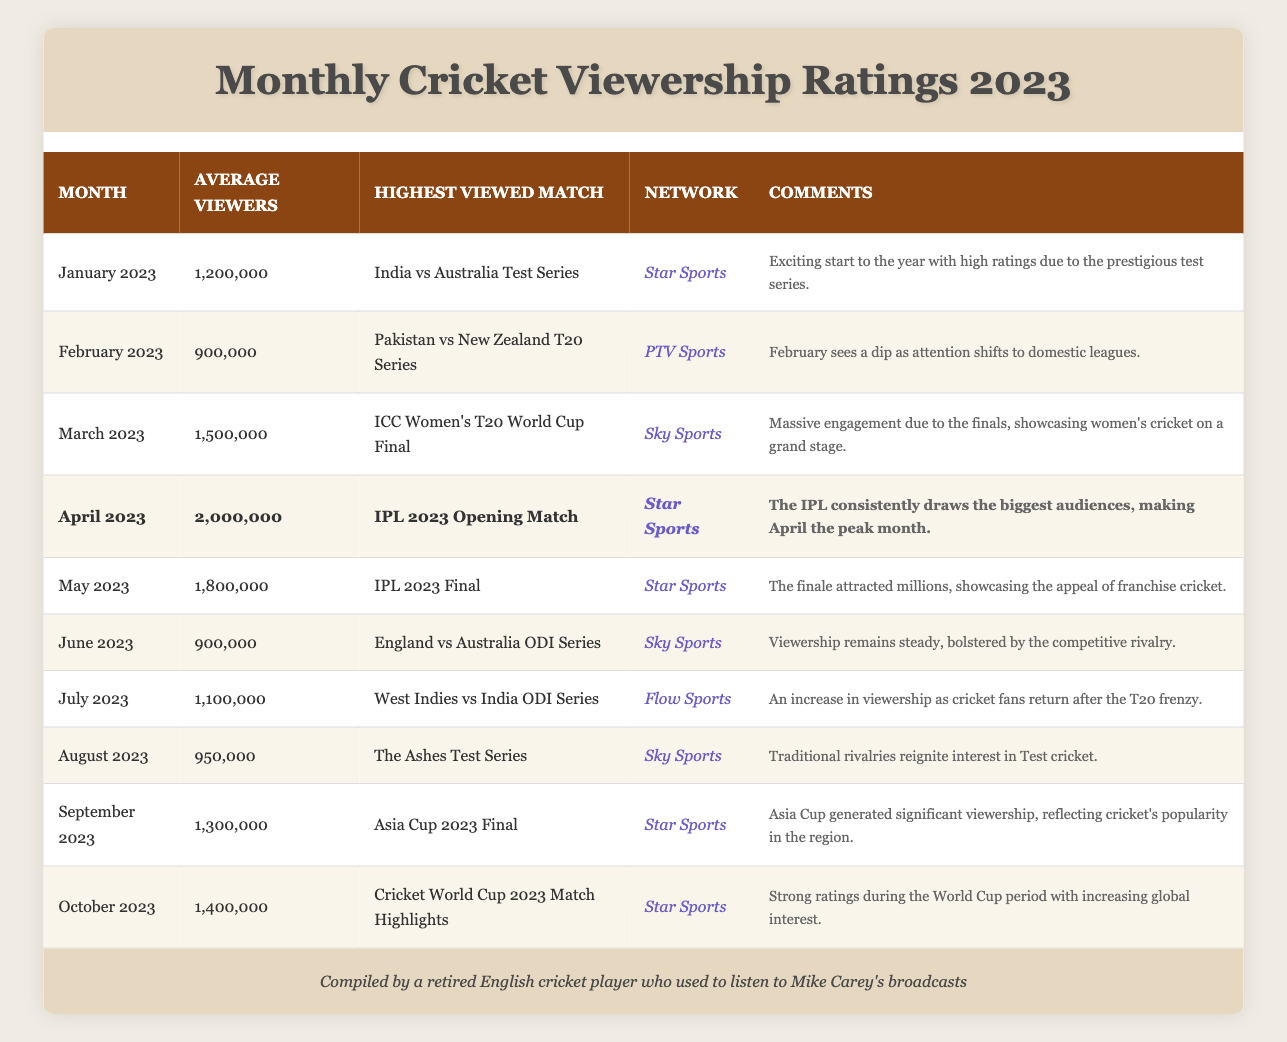What was the highest average viewership in 2023? The highest average viewership listed in the table is in April 2023, which has 2,000,000 viewers.
Answer: 2,000,000 Which match had the highest viewership in September 2023? The match with the highest viewership in September 2023 is the Asia Cup 2023 Final.
Answer: Asia Cup 2023 Final Was there an increase in viewership from July to August 2023? Yes, viewership increased from 1,100,000 in July to 950,000 in August. This shows a decrease, not an increase.
Answer: No Calculate the average viewership from January to March 2023. The viewerships for January (1,200,000), February (900,000), and March (1,500,000) sum to 3,600,000. Dividing this by 3 gives an average of 1,200,000.
Answer: 1,200,000 Which network aired the highest viewed match in April 2023? The highest viewed match in April 2023 was the IPL 2023 Opening Match, aired by Star Sports.
Answer: Star Sports Was the viewership in March higher than in May 2023? Yes, March had 1,500,000 viewers while May had 1,800,000 viewers, making March higher.
Answer: No What was the percentage drop in average viewers from April to May 2023? April had 2,000,000 viewers and May had 1,800,000 viewers. The drop is 200,000, which is (200,000/2,000,000) * 100 = 10%.
Answer: 10% Identify the only month in 2023 where viewership fell below 1,000,000. In June 2023, the average viewership fell to 900,000.
Answer: June 2023 Is it true that all matches aired by Star Sports had viewership above 1,000,000? This is false; in June, there was a match aired by Sky Sports with only 900,000 viewers.
Answer: No Which months saw an increase in average viewership compared to the previous month? The months with increased average viewership compared to the previous month are March to April and April to May.
Answer: March to April, and July to August What was the average viewership from June to August 2023? The viewerships for June (900,000), July (1,100,000), and August (950,000) total 2,950,000. The average is 2,950,000/3 = 983,333.
Answer: 983,333 